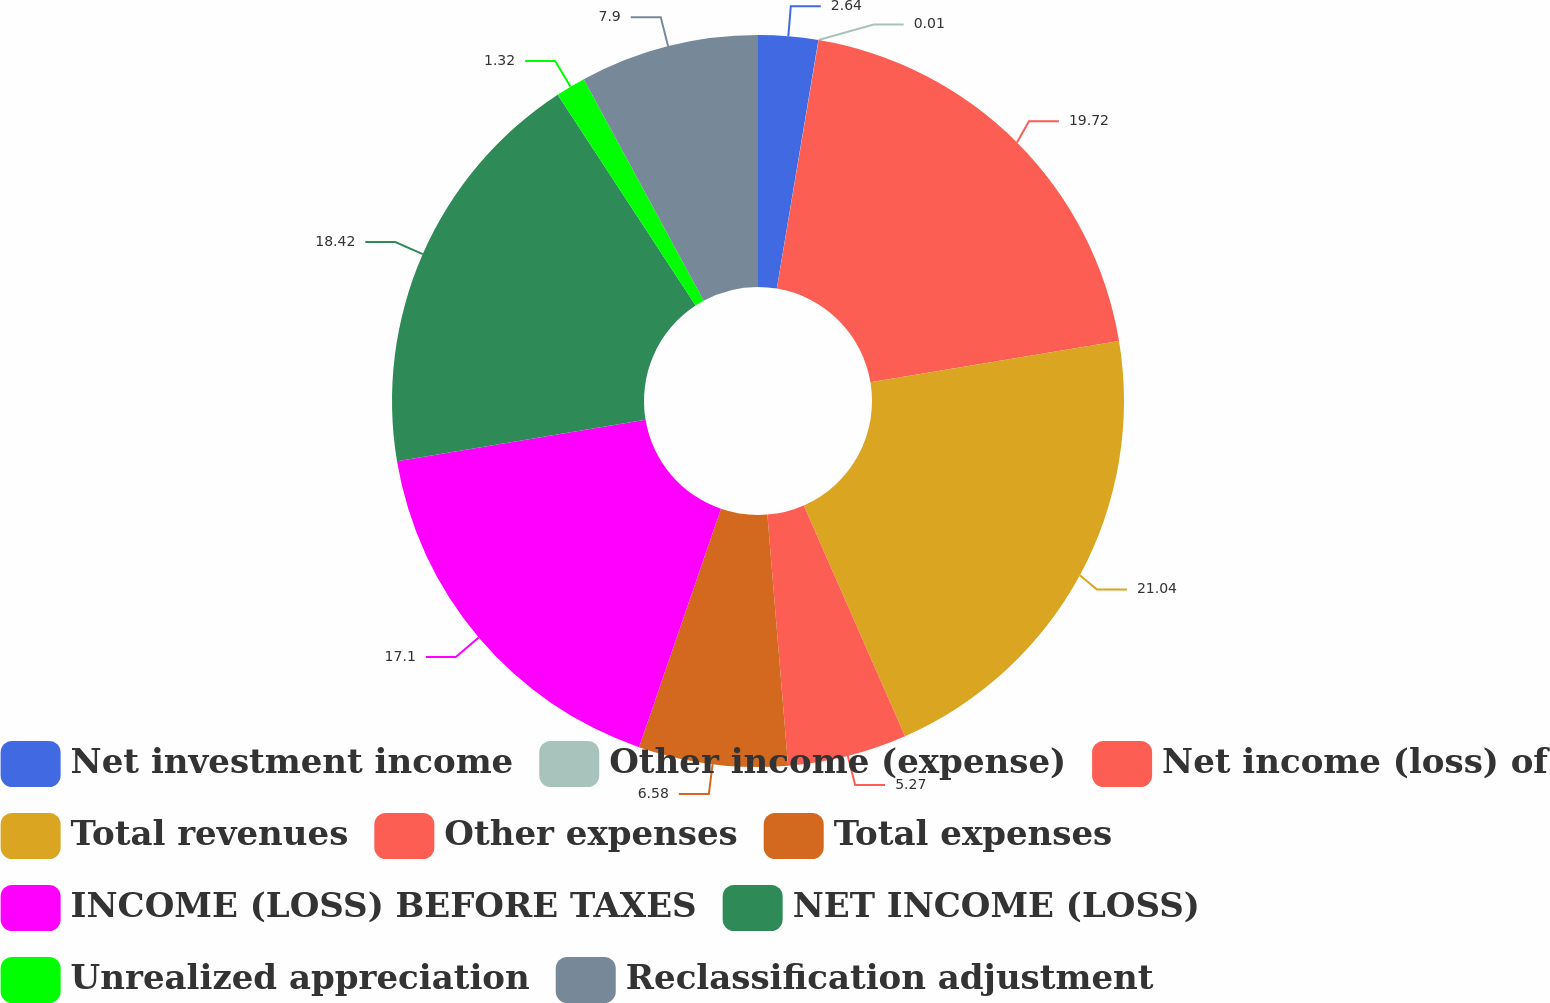Convert chart. <chart><loc_0><loc_0><loc_500><loc_500><pie_chart><fcel>Net investment income<fcel>Other income (expense)<fcel>Net income (loss) of<fcel>Total revenues<fcel>Other expenses<fcel>Total expenses<fcel>INCOME (LOSS) BEFORE TAXES<fcel>NET INCOME (LOSS)<fcel>Unrealized appreciation<fcel>Reclassification adjustment<nl><fcel>2.64%<fcel>0.01%<fcel>19.73%<fcel>21.05%<fcel>5.27%<fcel>6.58%<fcel>17.1%<fcel>18.42%<fcel>1.32%<fcel>7.9%<nl></chart> 